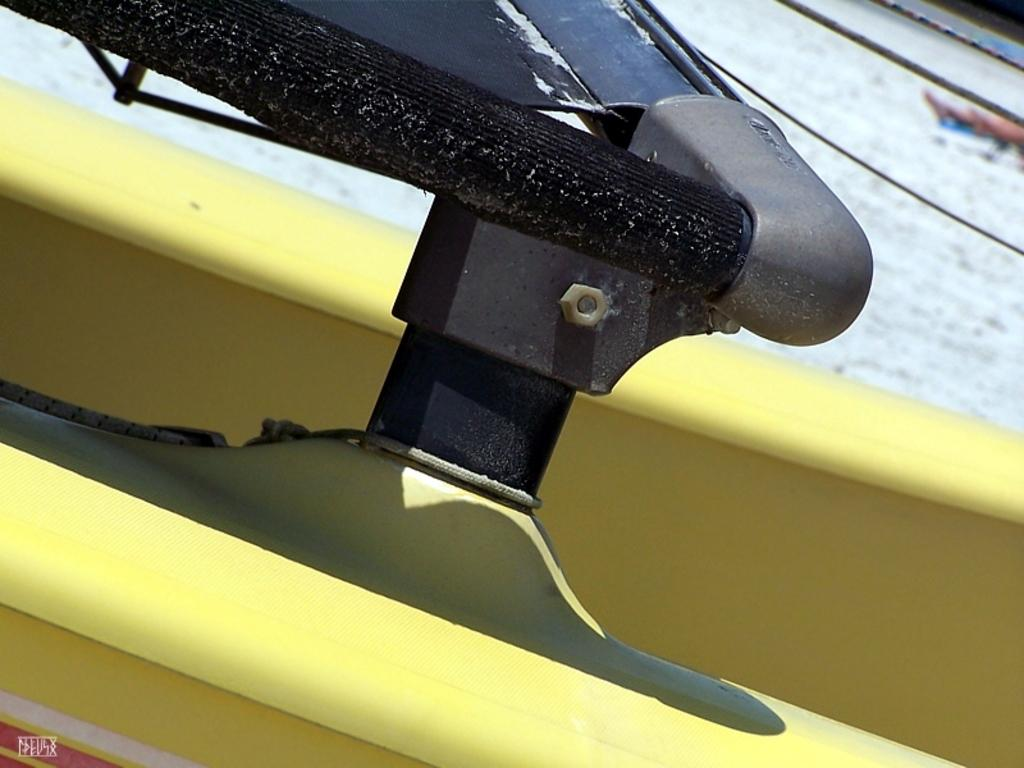What is the main subject of the image? The main subject of the image is a part of a boat. Are there any other boats visible in the image? Yes, there is another boat in the image. What can be seen connecting the boats or parts of the boats? Ropes are visible in the image. How would you describe the overall appearance of the image? The background of the image is slightly blurred. Can you tell me how many stems are growing from the boat in the image? There are no stems growing from the boat in the image. Is there a dog visible in the image? No, there is no dog present in the image. 